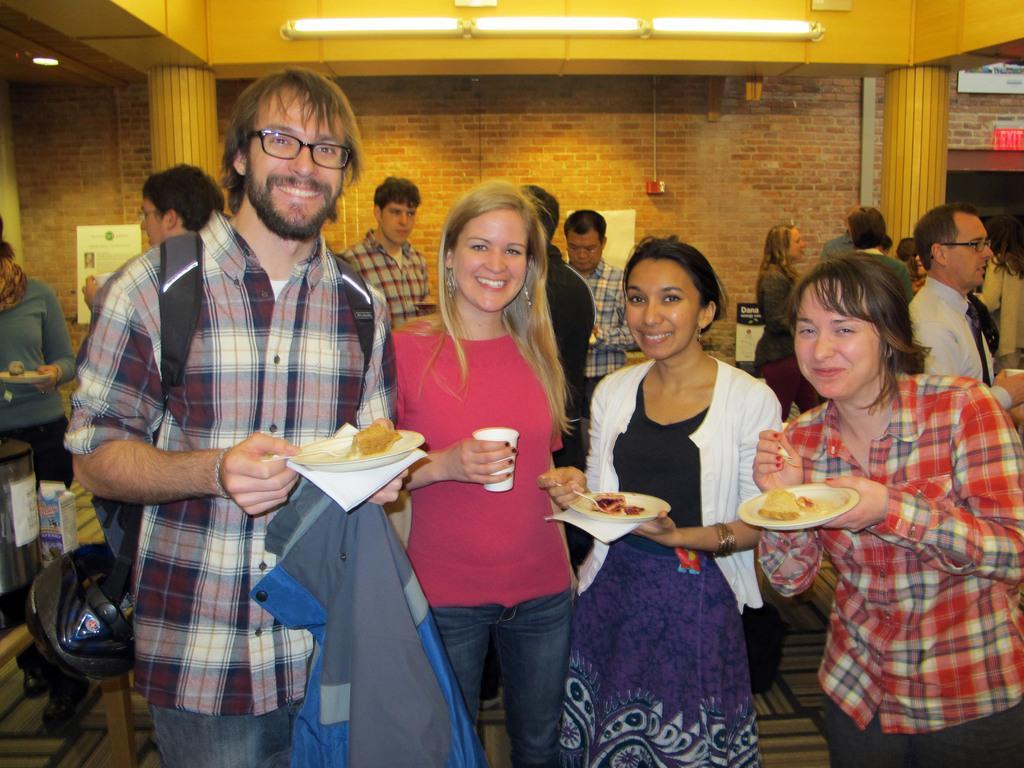Can you describe this image briefly? In this image we can see there are a few people standing and smiling and they are holding some objects in their hand. In the background there is a wall. 